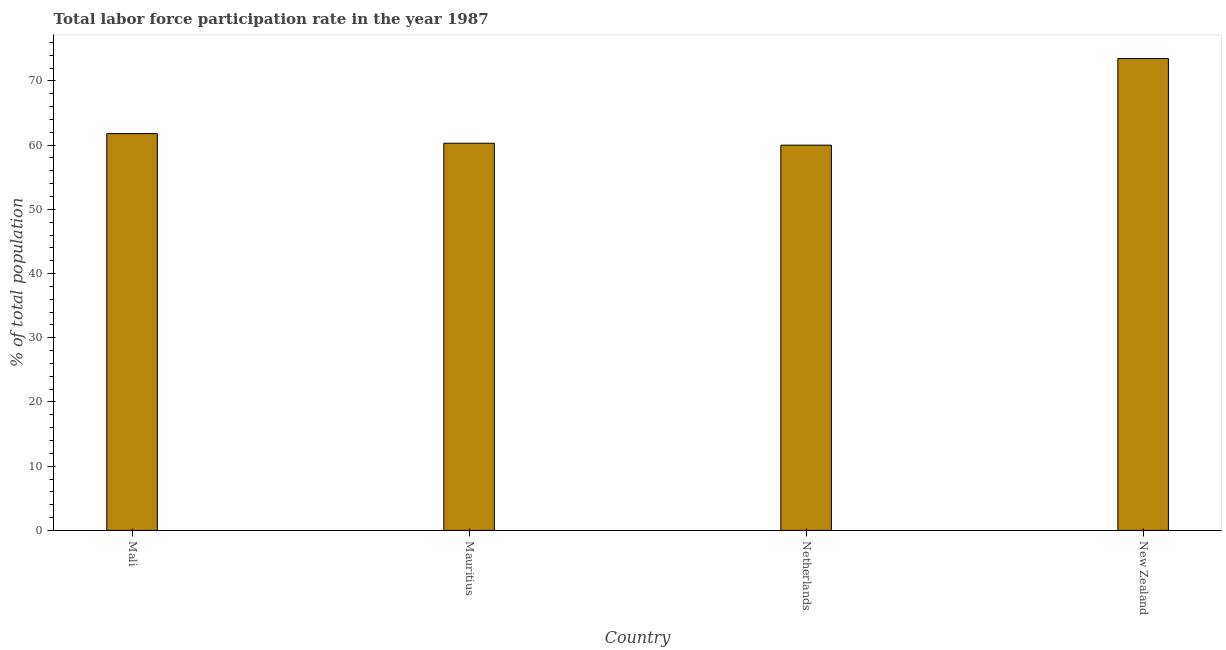Does the graph contain any zero values?
Your answer should be very brief. No. What is the title of the graph?
Provide a short and direct response. Total labor force participation rate in the year 1987. What is the label or title of the Y-axis?
Make the answer very short. % of total population. Across all countries, what is the maximum total labor force participation rate?
Give a very brief answer. 73.5. In which country was the total labor force participation rate maximum?
Make the answer very short. New Zealand. What is the sum of the total labor force participation rate?
Offer a terse response. 255.6. What is the difference between the total labor force participation rate in Mauritius and Netherlands?
Provide a succinct answer. 0.3. What is the average total labor force participation rate per country?
Keep it short and to the point. 63.9. What is the median total labor force participation rate?
Your response must be concise. 61.05. In how many countries, is the total labor force participation rate greater than 32 %?
Your answer should be compact. 4. What is the ratio of the total labor force participation rate in Mali to that in New Zealand?
Your answer should be compact. 0.84. Is the total labor force participation rate in Netherlands less than that in New Zealand?
Provide a short and direct response. Yes. Is the sum of the total labor force participation rate in Mauritius and Netherlands greater than the maximum total labor force participation rate across all countries?
Your answer should be very brief. Yes. What is the difference between the highest and the lowest total labor force participation rate?
Keep it short and to the point. 13.5. In how many countries, is the total labor force participation rate greater than the average total labor force participation rate taken over all countries?
Ensure brevity in your answer.  1. How many bars are there?
Your response must be concise. 4. Are all the bars in the graph horizontal?
Provide a short and direct response. No. What is the % of total population in Mali?
Offer a terse response. 61.8. What is the % of total population in Mauritius?
Your answer should be very brief. 60.3. What is the % of total population in Netherlands?
Offer a terse response. 60. What is the % of total population of New Zealand?
Give a very brief answer. 73.5. What is the difference between the % of total population in Mali and Mauritius?
Ensure brevity in your answer.  1.5. What is the difference between the % of total population in Netherlands and New Zealand?
Your answer should be compact. -13.5. What is the ratio of the % of total population in Mali to that in Mauritius?
Offer a terse response. 1.02. What is the ratio of the % of total population in Mali to that in Netherlands?
Your answer should be compact. 1.03. What is the ratio of the % of total population in Mali to that in New Zealand?
Offer a terse response. 0.84. What is the ratio of the % of total population in Mauritius to that in New Zealand?
Give a very brief answer. 0.82. What is the ratio of the % of total population in Netherlands to that in New Zealand?
Give a very brief answer. 0.82. 